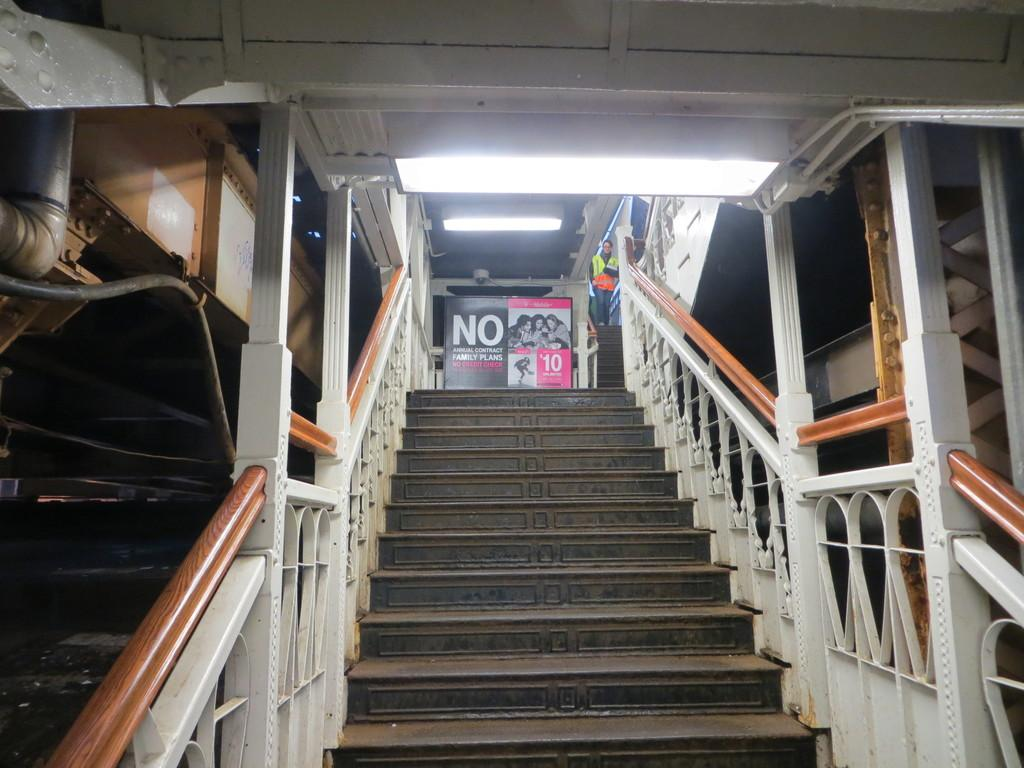What type of structure can be seen in the image? There are stairs in the image. What feature is present alongside the stairs? There is a railing in the image. What object is visible in the image that might be used for displaying information or advertisements? There is a board in the image. What can be seen providing illumination in the image? There are lights in the image. What type of vertical support can be seen in the image? There are poles in the image. What is the person in the image doing? A person is walking in the image. What material is used for some of the objects in the image? There are iron objects in the image. What type of twig can be seen in the person's hand in the image? There is no twig present in the image; the person is not holding any object. What is the title of the book the person is reading in the image? There is no book or title mentioned in the image; the person is walking. 